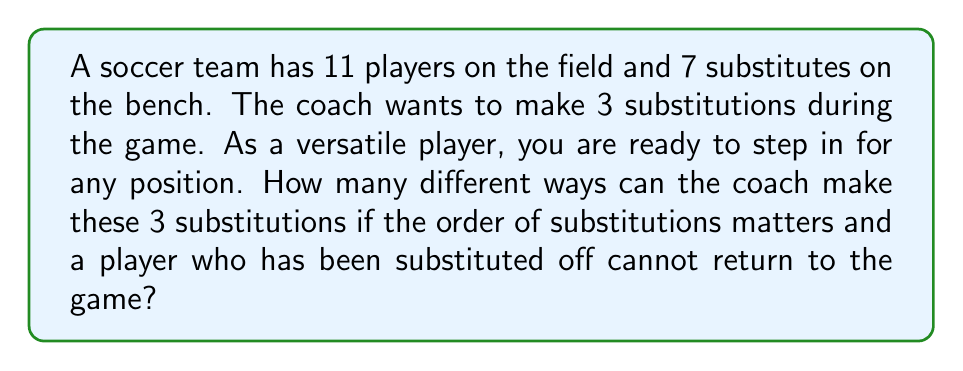Could you help me with this problem? Let's approach this step-by-step:

1) For the first substitution:
   - There are 11 players on the field who can be substituted off.
   - There are 7 substitutes (including you) who can come on.
   So, there are $11 \times 7 = 77$ possibilities for the first substitution.

2) For the second substitution:
   - There are still 11 players on the field who can be substituted off (10 original players plus 1 who just came on).
   - There are now 6 substitutes left on the bench.
   So, there are $11 \times 6 = 66$ possibilities for the second substitution.

3) For the third substitution:
   - Again, there are 11 players on the field who can be substituted off.
   - There are now 5 substitutes left on the bench.
   So, there are $11 \times 5 = 55$ possibilities for the third substitution.

4) Since the order of substitutions matters, we multiply these possibilities together:

   $$77 \times 66 \times 55 = 279,510$$

This is an application of the multiplication principle in counting.
Answer: There are 279,510 different ways the coach can make the 3 substitutions. 